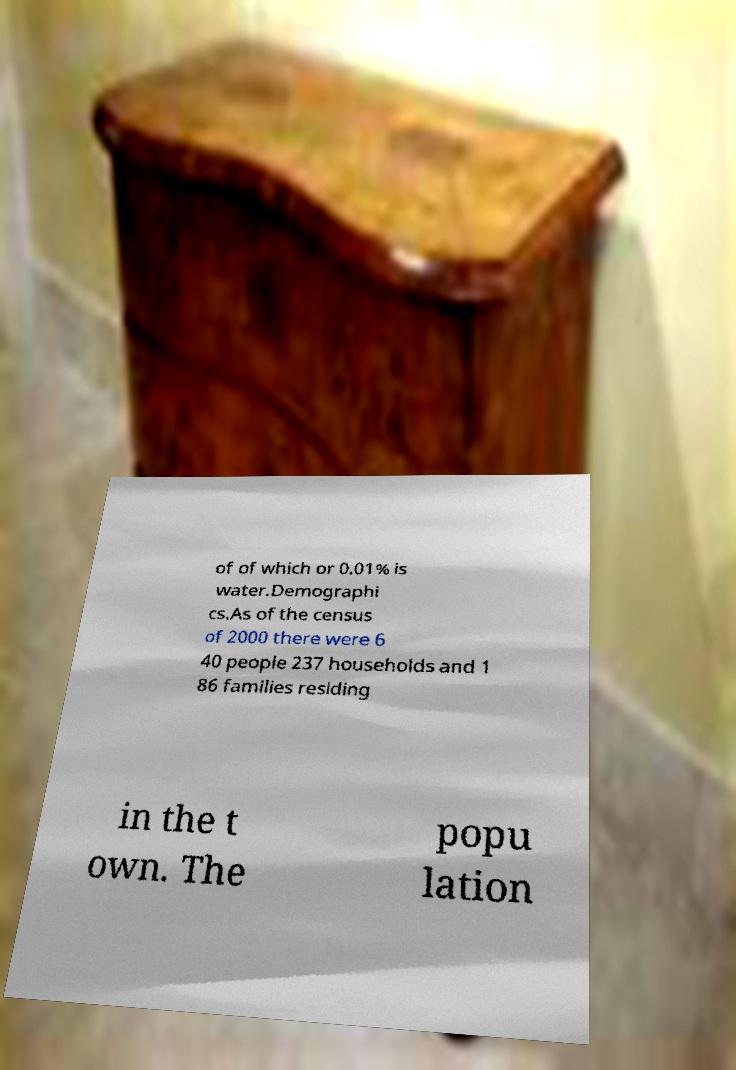Could you assist in decoding the text presented in this image and type it out clearly? of of which or 0.01% is water.Demographi cs.As of the census of 2000 there were 6 40 people 237 households and 1 86 families residing in the t own. The popu lation 